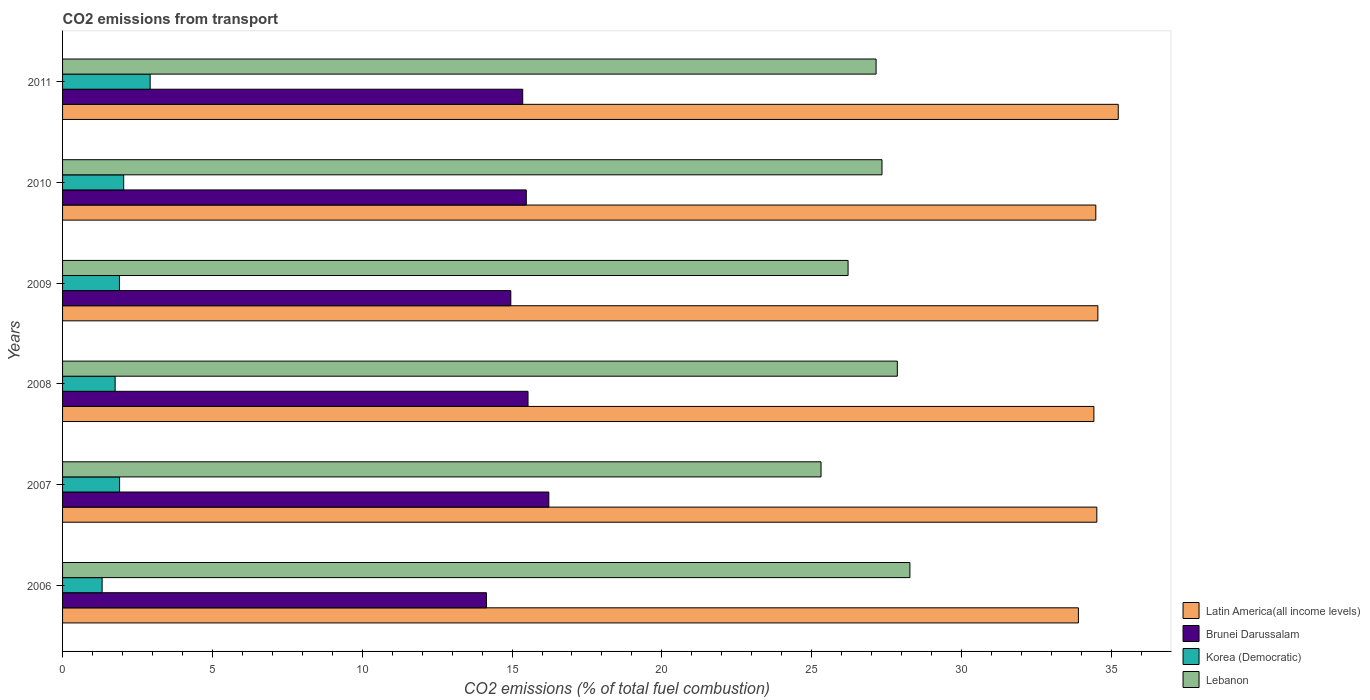Are the number of bars on each tick of the Y-axis equal?
Your answer should be very brief. Yes. How many bars are there on the 5th tick from the top?
Make the answer very short. 4. What is the total CO2 emitted in Lebanon in 2006?
Make the answer very short. 28.28. Across all years, what is the maximum total CO2 emitted in Latin America(all income levels)?
Your response must be concise. 35.23. Across all years, what is the minimum total CO2 emitted in Korea (Democratic)?
Make the answer very short. 1.32. In which year was the total CO2 emitted in Lebanon maximum?
Offer a very short reply. 2006. What is the total total CO2 emitted in Lebanon in the graph?
Your answer should be compact. 162.16. What is the difference between the total CO2 emitted in Lebanon in 2006 and that in 2010?
Give a very brief answer. 0.93. What is the difference between the total CO2 emitted in Korea (Democratic) in 2010 and the total CO2 emitted in Brunei Darussalam in 2008?
Your response must be concise. -13.49. What is the average total CO2 emitted in Brunei Darussalam per year?
Provide a short and direct response. 15.28. In the year 2010, what is the difference between the total CO2 emitted in Brunei Darussalam and total CO2 emitted in Latin America(all income levels)?
Offer a very short reply. -19.01. What is the ratio of the total CO2 emitted in Korea (Democratic) in 2008 to that in 2011?
Keep it short and to the point. 0.6. What is the difference between the highest and the second highest total CO2 emitted in Latin America(all income levels)?
Your answer should be compact. 0.68. What is the difference between the highest and the lowest total CO2 emitted in Latin America(all income levels)?
Ensure brevity in your answer.  1.33. What does the 2nd bar from the top in 2006 represents?
Make the answer very short. Korea (Democratic). What does the 2nd bar from the bottom in 2006 represents?
Your answer should be compact. Brunei Darussalam. How many bars are there?
Offer a terse response. 24. Are all the bars in the graph horizontal?
Offer a terse response. Yes. Does the graph contain any zero values?
Your answer should be compact. No. Does the graph contain grids?
Provide a short and direct response. No. How are the legend labels stacked?
Your answer should be very brief. Vertical. What is the title of the graph?
Make the answer very short. CO2 emissions from transport. Does "Bosnia and Herzegovina" appear as one of the legend labels in the graph?
Give a very brief answer. No. What is the label or title of the X-axis?
Make the answer very short. CO2 emissions (% of total fuel combustion). What is the CO2 emissions (% of total fuel combustion) of Latin America(all income levels) in 2006?
Your response must be concise. 33.9. What is the CO2 emissions (% of total fuel combustion) in Brunei Darussalam in 2006?
Offer a terse response. 14.15. What is the CO2 emissions (% of total fuel combustion) of Korea (Democratic) in 2006?
Offer a very short reply. 1.32. What is the CO2 emissions (% of total fuel combustion) in Lebanon in 2006?
Keep it short and to the point. 28.28. What is the CO2 emissions (% of total fuel combustion) of Latin America(all income levels) in 2007?
Keep it short and to the point. 34.52. What is the CO2 emissions (% of total fuel combustion) in Brunei Darussalam in 2007?
Keep it short and to the point. 16.23. What is the CO2 emissions (% of total fuel combustion) of Korea (Democratic) in 2007?
Give a very brief answer. 1.9. What is the CO2 emissions (% of total fuel combustion) of Lebanon in 2007?
Your answer should be compact. 25.31. What is the CO2 emissions (% of total fuel combustion) of Latin America(all income levels) in 2008?
Your answer should be very brief. 34.42. What is the CO2 emissions (% of total fuel combustion) in Brunei Darussalam in 2008?
Make the answer very short. 15.53. What is the CO2 emissions (% of total fuel combustion) in Korea (Democratic) in 2008?
Give a very brief answer. 1.75. What is the CO2 emissions (% of total fuel combustion) of Lebanon in 2008?
Your answer should be very brief. 27.86. What is the CO2 emissions (% of total fuel combustion) of Latin America(all income levels) in 2009?
Keep it short and to the point. 34.55. What is the CO2 emissions (% of total fuel combustion) in Brunei Darussalam in 2009?
Provide a succinct answer. 14.96. What is the CO2 emissions (% of total fuel combustion) of Korea (Democratic) in 2009?
Your answer should be compact. 1.9. What is the CO2 emissions (% of total fuel combustion) in Lebanon in 2009?
Provide a succinct answer. 26.22. What is the CO2 emissions (% of total fuel combustion) in Latin America(all income levels) in 2010?
Provide a succinct answer. 34.48. What is the CO2 emissions (% of total fuel combustion) in Brunei Darussalam in 2010?
Give a very brief answer. 15.48. What is the CO2 emissions (% of total fuel combustion) in Korea (Democratic) in 2010?
Your answer should be compact. 2.04. What is the CO2 emissions (% of total fuel combustion) in Lebanon in 2010?
Keep it short and to the point. 27.35. What is the CO2 emissions (% of total fuel combustion) of Latin America(all income levels) in 2011?
Give a very brief answer. 35.23. What is the CO2 emissions (% of total fuel combustion) in Brunei Darussalam in 2011?
Your answer should be very brief. 15.36. What is the CO2 emissions (% of total fuel combustion) of Korea (Democratic) in 2011?
Give a very brief answer. 2.92. What is the CO2 emissions (% of total fuel combustion) of Lebanon in 2011?
Your answer should be compact. 27.15. Across all years, what is the maximum CO2 emissions (% of total fuel combustion) of Latin America(all income levels)?
Offer a terse response. 35.23. Across all years, what is the maximum CO2 emissions (% of total fuel combustion) in Brunei Darussalam?
Keep it short and to the point. 16.23. Across all years, what is the maximum CO2 emissions (% of total fuel combustion) in Korea (Democratic)?
Offer a terse response. 2.92. Across all years, what is the maximum CO2 emissions (% of total fuel combustion) in Lebanon?
Your response must be concise. 28.28. Across all years, what is the minimum CO2 emissions (% of total fuel combustion) in Latin America(all income levels)?
Provide a short and direct response. 33.9. Across all years, what is the minimum CO2 emissions (% of total fuel combustion) of Brunei Darussalam?
Your answer should be very brief. 14.15. Across all years, what is the minimum CO2 emissions (% of total fuel combustion) of Korea (Democratic)?
Offer a terse response. 1.32. Across all years, what is the minimum CO2 emissions (% of total fuel combustion) in Lebanon?
Give a very brief answer. 25.31. What is the total CO2 emissions (% of total fuel combustion) of Latin America(all income levels) in the graph?
Provide a short and direct response. 207.1. What is the total CO2 emissions (% of total fuel combustion) in Brunei Darussalam in the graph?
Keep it short and to the point. 91.7. What is the total CO2 emissions (% of total fuel combustion) of Korea (Democratic) in the graph?
Offer a terse response. 11.84. What is the total CO2 emissions (% of total fuel combustion) in Lebanon in the graph?
Provide a short and direct response. 162.16. What is the difference between the CO2 emissions (% of total fuel combustion) in Latin America(all income levels) in 2006 and that in 2007?
Offer a terse response. -0.61. What is the difference between the CO2 emissions (% of total fuel combustion) in Brunei Darussalam in 2006 and that in 2007?
Provide a succinct answer. -2.08. What is the difference between the CO2 emissions (% of total fuel combustion) of Korea (Democratic) in 2006 and that in 2007?
Provide a succinct answer. -0.58. What is the difference between the CO2 emissions (% of total fuel combustion) in Lebanon in 2006 and that in 2007?
Your answer should be compact. 2.97. What is the difference between the CO2 emissions (% of total fuel combustion) of Latin America(all income levels) in 2006 and that in 2008?
Keep it short and to the point. -0.52. What is the difference between the CO2 emissions (% of total fuel combustion) in Brunei Darussalam in 2006 and that in 2008?
Provide a succinct answer. -1.39. What is the difference between the CO2 emissions (% of total fuel combustion) in Korea (Democratic) in 2006 and that in 2008?
Give a very brief answer. -0.43. What is the difference between the CO2 emissions (% of total fuel combustion) of Lebanon in 2006 and that in 2008?
Offer a very short reply. 0.42. What is the difference between the CO2 emissions (% of total fuel combustion) in Latin America(all income levels) in 2006 and that in 2009?
Keep it short and to the point. -0.65. What is the difference between the CO2 emissions (% of total fuel combustion) in Brunei Darussalam in 2006 and that in 2009?
Provide a succinct answer. -0.81. What is the difference between the CO2 emissions (% of total fuel combustion) of Korea (Democratic) in 2006 and that in 2009?
Your response must be concise. -0.58. What is the difference between the CO2 emissions (% of total fuel combustion) of Lebanon in 2006 and that in 2009?
Make the answer very short. 2.06. What is the difference between the CO2 emissions (% of total fuel combustion) in Latin America(all income levels) in 2006 and that in 2010?
Provide a short and direct response. -0.58. What is the difference between the CO2 emissions (% of total fuel combustion) of Brunei Darussalam in 2006 and that in 2010?
Provide a succinct answer. -1.33. What is the difference between the CO2 emissions (% of total fuel combustion) in Korea (Democratic) in 2006 and that in 2010?
Keep it short and to the point. -0.72. What is the difference between the CO2 emissions (% of total fuel combustion) of Lebanon in 2006 and that in 2010?
Your response must be concise. 0.93. What is the difference between the CO2 emissions (% of total fuel combustion) in Latin America(all income levels) in 2006 and that in 2011?
Your answer should be compact. -1.33. What is the difference between the CO2 emissions (% of total fuel combustion) in Brunei Darussalam in 2006 and that in 2011?
Keep it short and to the point. -1.21. What is the difference between the CO2 emissions (% of total fuel combustion) in Korea (Democratic) in 2006 and that in 2011?
Your answer should be very brief. -1.6. What is the difference between the CO2 emissions (% of total fuel combustion) in Lebanon in 2006 and that in 2011?
Keep it short and to the point. 1.13. What is the difference between the CO2 emissions (% of total fuel combustion) of Latin America(all income levels) in 2007 and that in 2008?
Give a very brief answer. 0.1. What is the difference between the CO2 emissions (% of total fuel combustion) in Brunei Darussalam in 2007 and that in 2008?
Make the answer very short. 0.69. What is the difference between the CO2 emissions (% of total fuel combustion) of Korea (Democratic) in 2007 and that in 2008?
Ensure brevity in your answer.  0.15. What is the difference between the CO2 emissions (% of total fuel combustion) in Lebanon in 2007 and that in 2008?
Your answer should be very brief. -2.55. What is the difference between the CO2 emissions (% of total fuel combustion) in Latin America(all income levels) in 2007 and that in 2009?
Your answer should be very brief. -0.03. What is the difference between the CO2 emissions (% of total fuel combustion) of Brunei Darussalam in 2007 and that in 2009?
Make the answer very short. 1.27. What is the difference between the CO2 emissions (% of total fuel combustion) of Korea (Democratic) in 2007 and that in 2009?
Offer a very short reply. 0. What is the difference between the CO2 emissions (% of total fuel combustion) of Lebanon in 2007 and that in 2009?
Ensure brevity in your answer.  -0.9. What is the difference between the CO2 emissions (% of total fuel combustion) of Latin America(all income levels) in 2007 and that in 2010?
Provide a succinct answer. 0.03. What is the difference between the CO2 emissions (% of total fuel combustion) of Brunei Darussalam in 2007 and that in 2010?
Your response must be concise. 0.75. What is the difference between the CO2 emissions (% of total fuel combustion) in Korea (Democratic) in 2007 and that in 2010?
Your answer should be compact. -0.14. What is the difference between the CO2 emissions (% of total fuel combustion) in Lebanon in 2007 and that in 2010?
Make the answer very short. -2.03. What is the difference between the CO2 emissions (% of total fuel combustion) in Latin America(all income levels) in 2007 and that in 2011?
Your answer should be very brief. -0.72. What is the difference between the CO2 emissions (% of total fuel combustion) of Brunei Darussalam in 2007 and that in 2011?
Offer a terse response. 0.87. What is the difference between the CO2 emissions (% of total fuel combustion) in Korea (Democratic) in 2007 and that in 2011?
Ensure brevity in your answer.  -1.02. What is the difference between the CO2 emissions (% of total fuel combustion) of Lebanon in 2007 and that in 2011?
Your response must be concise. -1.84. What is the difference between the CO2 emissions (% of total fuel combustion) of Latin America(all income levels) in 2008 and that in 2009?
Your answer should be very brief. -0.13. What is the difference between the CO2 emissions (% of total fuel combustion) in Brunei Darussalam in 2008 and that in 2009?
Offer a very short reply. 0.57. What is the difference between the CO2 emissions (% of total fuel combustion) in Korea (Democratic) in 2008 and that in 2009?
Offer a very short reply. -0.14. What is the difference between the CO2 emissions (% of total fuel combustion) of Lebanon in 2008 and that in 2009?
Ensure brevity in your answer.  1.64. What is the difference between the CO2 emissions (% of total fuel combustion) of Latin America(all income levels) in 2008 and that in 2010?
Your answer should be very brief. -0.06. What is the difference between the CO2 emissions (% of total fuel combustion) in Brunei Darussalam in 2008 and that in 2010?
Offer a very short reply. 0.06. What is the difference between the CO2 emissions (% of total fuel combustion) in Korea (Democratic) in 2008 and that in 2010?
Provide a succinct answer. -0.28. What is the difference between the CO2 emissions (% of total fuel combustion) in Lebanon in 2008 and that in 2010?
Provide a succinct answer. 0.51. What is the difference between the CO2 emissions (% of total fuel combustion) in Latin America(all income levels) in 2008 and that in 2011?
Give a very brief answer. -0.81. What is the difference between the CO2 emissions (% of total fuel combustion) of Brunei Darussalam in 2008 and that in 2011?
Offer a very short reply. 0.18. What is the difference between the CO2 emissions (% of total fuel combustion) in Korea (Democratic) in 2008 and that in 2011?
Provide a succinct answer. -1.17. What is the difference between the CO2 emissions (% of total fuel combustion) of Lebanon in 2008 and that in 2011?
Keep it short and to the point. 0.71. What is the difference between the CO2 emissions (% of total fuel combustion) of Latin America(all income levels) in 2009 and that in 2010?
Make the answer very short. 0.07. What is the difference between the CO2 emissions (% of total fuel combustion) of Brunei Darussalam in 2009 and that in 2010?
Make the answer very short. -0.52. What is the difference between the CO2 emissions (% of total fuel combustion) in Korea (Democratic) in 2009 and that in 2010?
Your answer should be compact. -0.14. What is the difference between the CO2 emissions (% of total fuel combustion) of Lebanon in 2009 and that in 2010?
Keep it short and to the point. -1.13. What is the difference between the CO2 emissions (% of total fuel combustion) of Latin America(all income levels) in 2009 and that in 2011?
Give a very brief answer. -0.68. What is the difference between the CO2 emissions (% of total fuel combustion) of Brunei Darussalam in 2009 and that in 2011?
Make the answer very short. -0.4. What is the difference between the CO2 emissions (% of total fuel combustion) of Korea (Democratic) in 2009 and that in 2011?
Keep it short and to the point. -1.02. What is the difference between the CO2 emissions (% of total fuel combustion) in Lebanon in 2009 and that in 2011?
Provide a short and direct response. -0.93. What is the difference between the CO2 emissions (% of total fuel combustion) of Latin America(all income levels) in 2010 and that in 2011?
Offer a very short reply. -0.75. What is the difference between the CO2 emissions (% of total fuel combustion) of Brunei Darussalam in 2010 and that in 2011?
Give a very brief answer. 0.12. What is the difference between the CO2 emissions (% of total fuel combustion) of Korea (Democratic) in 2010 and that in 2011?
Ensure brevity in your answer.  -0.88. What is the difference between the CO2 emissions (% of total fuel combustion) of Lebanon in 2010 and that in 2011?
Your response must be concise. 0.2. What is the difference between the CO2 emissions (% of total fuel combustion) in Latin America(all income levels) in 2006 and the CO2 emissions (% of total fuel combustion) in Brunei Darussalam in 2007?
Your response must be concise. 17.67. What is the difference between the CO2 emissions (% of total fuel combustion) in Latin America(all income levels) in 2006 and the CO2 emissions (% of total fuel combustion) in Korea (Democratic) in 2007?
Make the answer very short. 32. What is the difference between the CO2 emissions (% of total fuel combustion) of Latin America(all income levels) in 2006 and the CO2 emissions (% of total fuel combustion) of Lebanon in 2007?
Ensure brevity in your answer.  8.59. What is the difference between the CO2 emissions (% of total fuel combustion) of Brunei Darussalam in 2006 and the CO2 emissions (% of total fuel combustion) of Korea (Democratic) in 2007?
Make the answer very short. 12.24. What is the difference between the CO2 emissions (% of total fuel combustion) of Brunei Darussalam in 2006 and the CO2 emissions (% of total fuel combustion) of Lebanon in 2007?
Ensure brevity in your answer.  -11.17. What is the difference between the CO2 emissions (% of total fuel combustion) in Korea (Democratic) in 2006 and the CO2 emissions (% of total fuel combustion) in Lebanon in 2007?
Provide a succinct answer. -23.99. What is the difference between the CO2 emissions (% of total fuel combustion) of Latin America(all income levels) in 2006 and the CO2 emissions (% of total fuel combustion) of Brunei Darussalam in 2008?
Offer a very short reply. 18.37. What is the difference between the CO2 emissions (% of total fuel combustion) of Latin America(all income levels) in 2006 and the CO2 emissions (% of total fuel combustion) of Korea (Democratic) in 2008?
Provide a short and direct response. 32.15. What is the difference between the CO2 emissions (% of total fuel combustion) of Latin America(all income levels) in 2006 and the CO2 emissions (% of total fuel combustion) of Lebanon in 2008?
Offer a very short reply. 6.04. What is the difference between the CO2 emissions (% of total fuel combustion) of Brunei Darussalam in 2006 and the CO2 emissions (% of total fuel combustion) of Korea (Democratic) in 2008?
Your answer should be compact. 12.39. What is the difference between the CO2 emissions (% of total fuel combustion) of Brunei Darussalam in 2006 and the CO2 emissions (% of total fuel combustion) of Lebanon in 2008?
Make the answer very short. -13.71. What is the difference between the CO2 emissions (% of total fuel combustion) in Korea (Democratic) in 2006 and the CO2 emissions (% of total fuel combustion) in Lebanon in 2008?
Keep it short and to the point. -26.54. What is the difference between the CO2 emissions (% of total fuel combustion) of Latin America(all income levels) in 2006 and the CO2 emissions (% of total fuel combustion) of Brunei Darussalam in 2009?
Provide a short and direct response. 18.94. What is the difference between the CO2 emissions (% of total fuel combustion) in Latin America(all income levels) in 2006 and the CO2 emissions (% of total fuel combustion) in Korea (Democratic) in 2009?
Your answer should be very brief. 32. What is the difference between the CO2 emissions (% of total fuel combustion) in Latin America(all income levels) in 2006 and the CO2 emissions (% of total fuel combustion) in Lebanon in 2009?
Your answer should be compact. 7.69. What is the difference between the CO2 emissions (% of total fuel combustion) in Brunei Darussalam in 2006 and the CO2 emissions (% of total fuel combustion) in Korea (Democratic) in 2009?
Keep it short and to the point. 12.25. What is the difference between the CO2 emissions (% of total fuel combustion) in Brunei Darussalam in 2006 and the CO2 emissions (% of total fuel combustion) in Lebanon in 2009?
Offer a terse response. -12.07. What is the difference between the CO2 emissions (% of total fuel combustion) of Korea (Democratic) in 2006 and the CO2 emissions (% of total fuel combustion) of Lebanon in 2009?
Keep it short and to the point. -24.89. What is the difference between the CO2 emissions (% of total fuel combustion) of Latin America(all income levels) in 2006 and the CO2 emissions (% of total fuel combustion) of Brunei Darussalam in 2010?
Keep it short and to the point. 18.43. What is the difference between the CO2 emissions (% of total fuel combustion) of Latin America(all income levels) in 2006 and the CO2 emissions (% of total fuel combustion) of Korea (Democratic) in 2010?
Keep it short and to the point. 31.86. What is the difference between the CO2 emissions (% of total fuel combustion) of Latin America(all income levels) in 2006 and the CO2 emissions (% of total fuel combustion) of Lebanon in 2010?
Provide a short and direct response. 6.55. What is the difference between the CO2 emissions (% of total fuel combustion) of Brunei Darussalam in 2006 and the CO2 emissions (% of total fuel combustion) of Korea (Democratic) in 2010?
Provide a succinct answer. 12.11. What is the difference between the CO2 emissions (% of total fuel combustion) of Brunei Darussalam in 2006 and the CO2 emissions (% of total fuel combustion) of Lebanon in 2010?
Your response must be concise. -13.2. What is the difference between the CO2 emissions (% of total fuel combustion) in Korea (Democratic) in 2006 and the CO2 emissions (% of total fuel combustion) in Lebanon in 2010?
Give a very brief answer. -26.03. What is the difference between the CO2 emissions (% of total fuel combustion) of Latin America(all income levels) in 2006 and the CO2 emissions (% of total fuel combustion) of Brunei Darussalam in 2011?
Make the answer very short. 18.54. What is the difference between the CO2 emissions (% of total fuel combustion) in Latin America(all income levels) in 2006 and the CO2 emissions (% of total fuel combustion) in Korea (Democratic) in 2011?
Your answer should be very brief. 30.98. What is the difference between the CO2 emissions (% of total fuel combustion) in Latin America(all income levels) in 2006 and the CO2 emissions (% of total fuel combustion) in Lebanon in 2011?
Provide a succinct answer. 6.75. What is the difference between the CO2 emissions (% of total fuel combustion) in Brunei Darussalam in 2006 and the CO2 emissions (% of total fuel combustion) in Korea (Democratic) in 2011?
Keep it short and to the point. 11.22. What is the difference between the CO2 emissions (% of total fuel combustion) of Brunei Darussalam in 2006 and the CO2 emissions (% of total fuel combustion) of Lebanon in 2011?
Your answer should be compact. -13. What is the difference between the CO2 emissions (% of total fuel combustion) of Korea (Democratic) in 2006 and the CO2 emissions (% of total fuel combustion) of Lebanon in 2011?
Your answer should be compact. -25.83. What is the difference between the CO2 emissions (% of total fuel combustion) in Latin America(all income levels) in 2007 and the CO2 emissions (% of total fuel combustion) in Brunei Darussalam in 2008?
Offer a terse response. 18.98. What is the difference between the CO2 emissions (% of total fuel combustion) in Latin America(all income levels) in 2007 and the CO2 emissions (% of total fuel combustion) in Korea (Democratic) in 2008?
Provide a succinct answer. 32.76. What is the difference between the CO2 emissions (% of total fuel combustion) in Latin America(all income levels) in 2007 and the CO2 emissions (% of total fuel combustion) in Lebanon in 2008?
Keep it short and to the point. 6.66. What is the difference between the CO2 emissions (% of total fuel combustion) in Brunei Darussalam in 2007 and the CO2 emissions (% of total fuel combustion) in Korea (Democratic) in 2008?
Your answer should be compact. 14.47. What is the difference between the CO2 emissions (% of total fuel combustion) of Brunei Darussalam in 2007 and the CO2 emissions (% of total fuel combustion) of Lebanon in 2008?
Keep it short and to the point. -11.63. What is the difference between the CO2 emissions (% of total fuel combustion) of Korea (Democratic) in 2007 and the CO2 emissions (% of total fuel combustion) of Lebanon in 2008?
Offer a terse response. -25.96. What is the difference between the CO2 emissions (% of total fuel combustion) in Latin America(all income levels) in 2007 and the CO2 emissions (% of total fuel combustion) in Brunei Darussalam in 2009?
Give a very brief answer. 19.56. What is the difference between the CO2 emissions (% of total fuel combustion) of Latin America(all income levels) in 2007 and the CO2 emissions (% of total fuel combustion) of Korea (Democratic) in 2009?
Offer a terse response. 32.62. What is the difference between the CO2 emissions (% of total fuel combustion) of Latin America(all income levels) in 2007 and the CO2 emissions (% of total fuel combustion) of Lebanon in 2009?
Make the answer very short. 8.3. What is the difference between the CO2 emissions (% of total fuel combustion) of Brunei Darussalam in 2007 and the CO2 emissions (% of total fuel combustion) of Korea (Democratic) in 2009?
Your answer should be compact. 14.33. What is the difference between the CO2 emissions (% of total fuel combustion) of Brunei Darussalam in 2007 and the CO2 emissions (% of total fuel combustion) of Lebanon in 2009?
Your response must be concise. -9.99. What is the difference between the CO2 emissions (% of total fuel combustion) in Korea (Democratic) in 2007 and the CO2 emissions (% of total fuel combustion) in Lebanon in 2009?
Give a very brief answer. -24.31. What is the difference between the CO2 emissions (% of total fuel combustion) in Latin America(all income levels) in 2007 and the CO2 emissions (% of total fuel combustion) in Brunei Darussalam in 2010?
Make the answer very short. 19.04. What is the difference between the CO2 emissions (% of total fuel combustion) in Latin America(all income levels) in 2007 and the CO2 emissions (% of total fuel combustion) in Korea (Democratic) in 2010?
Your answer should be very brief. 32.48. What is the difference between the CO2 emissions (% of total fuel combustion) of Latin America(all income levels) in 2007 and the CO2 emissions (% of total fuel combustion) of Lebanon in 2010?
Make the answer very short. 7.17. What is the difference between the CO2 emissions (% of total fuel combustion) in Brunei Darussalam in 2007 and the CO2 emissions (% of total fuel combustion) in Korea (Democratic) in 2010?
Ensure brevity in your answer.  14.19. What is the difference between the CO2 emissions (% of total fuel combustion) of Brunei Darussalam in 2007 and the CO2 emissions (% of total fuel combustion) of Lebanon in 2010?
Provide a short and direct response. -11.12. What is the difference between the CO2 emissions (% of total fuel combustion) of Korea (Democratic) in 2007 and the CO2 emissions (% of total fuel combustion) of Lebanon in 2010?
Keep it short and to the point. -25.44. What is the difference between the CO2 emissions (% of total fuel combustion) of Latin America(all income levels) in 2007 and the CO2 emissions (% of total fuel combustion) of Brunei Darussalam in 2011?
Make the answer very short. 19.16. What is the difference between the CO2 emissions (% of total fuel combustion) of Latin America(all income levels) in 2007 and the CO2 emissions (% of total fuel combustion) of Korea (Democratic) in 2011?
Your answer should be compact. 31.59. What is the difference between the CO2 emissions (% of total fuel combustion) in Latin America(all income levels) in 2007 and the CO2 emissions (% of total fuel combustion) in Lebanon in 2011?
Your response must be concise. 7.37. What is the difference between the CO2 emissions (% of total fuel combustion) in Brunei Darussalam in 2007 and the CO2 emissions (% of total fuel combustion) in Korea (Democratic) in 2011?
Your answer should be compact. 13.31. What is the difference between the CO2 emissions (% of total fuel combustion) of Brunei Darussalam in 2007 and the CO2 emissions (% of total fuel combustion) of Lebanon in 2011?
Your answer should be very brief. -10.92. What is the difference between the CO2 emissions (% of total fuel combustion) of Korea (Democratic) in 2007 and the CO2 emissions (% of total fuel combustion) of Lebanon in 2011?
Give a very brief answer. -25.25. What is the difference between the CO2 emissions (% of total fuel combustion) in Latin America(all income levels) in 2008 and the CO2 emissions (% of total fuel combustion) in Brunei Darussalam in 2009?
Make the answer very short. 19.46. What is the difference between the CO2 emissions (% of total fuel combustion) of Latin America(all income levels) in 2008 and the CO2 emissions (% of total fuel combustion) of Korea (Democratic) in 2009?
Ensure brevity in your answer.  32.52. What is the difference between the CO2 emissions (% of total fuel combustion) in Latin America(all income levels) in 2008 and the CO2 emissions (% of total fuel combustion) in Lebanon in 2009?
Your answer should be compact. 8.2. What is the difference between the CO2 emissions (% of total fuel combustion) in Brunei Darussalam in 2008 and the CO2 emissions (% of total fuel combustion) in Korea (Democratic) in 2009?
Keep it short and to the point. 13.64. What is the difference between the CO2 emissions (% of total fuel combustion) of Brunei Darussalam in 2008 and the CO2 emissions (% of total fuel combustion) of Lebanon in 2009?
Offer a very short reply. -10.68. What is the difference between the CO2 emissions (% of total fuel combustion) in Korea (Democratic) in 2008 and the CO2 emissions (% of total fuel combustion) in Lebanon in 2009?
Your answer should be compact. -24.46. What is the difference between the CO2 emissions (% of total fuel combustion) in Latin America(all income levels) in 2008 and the CO2 emissions (% of total fuel combustion) in Brunei Darussalam in 2010?
Provide a succinct answer. 18.94. What is the difference between the CO2 emissions (% of total fuel combustion) of Latin America(all income levels) in 2008 and the CO2 emissions (% of total fuel combustion) of Korea (Democratic) in 2010?
Keep it short and to the point. 32.38. What is the difference between the CO2 emissions (% of total fuel combustion) in Latin America(all income levels) in 2008 and the CO2 emissions (% of total fuel combustion) in Lebanon in 2010?
Provide a short and direct response. 7.07. What is the difference between the CO2 emissions (% of total fuel combustion) of Brunei Darussalam in 2008 and the CO2 emissions (% of total fuel combustion) of Korea (Democratic) in 2010?
Ensure brevity in your answer.  13.49. What is the difference between the CO2 emissions (% of total fuel combustion) of Brunei Darussalam in 2008 and the CO2 emissions (% of total fuel combustion) of Lebanon in 2010?
Keep it short and to the point. -11.81. What is the difference between the CO2 emissions (% of total fuel combustion) in Korea (Democratic) in 2008 and the CO2 emissions (% of total fuel combustion) in Lebanon in 2010?
Your answer should be very brief. -25.59. What is the difference between the CO2 emissions (% of total fuel combustion) in Latin America(all income levels) in 2008 and the CO2 emissions (% of total fuel combustion) in Brunei Darussalam in 2011?
Provide a succinct answer. 19.06. What is the difference between the CO2 emissions (% of total fuel combustion) in Latin America(all income levels) in 2008 and the CO2 emissions (% of total fuel combustion) in Korea (Democratic) in 2011?
Your answer should be compact. 31.5. What is the difference between the CO2 emissions (% of total fuel combustion) of Latin America(all income levels) in 2008 and the CO2 emissions (% of total fuel combustion) of Lebanon in 2011?
Give a very brief answer. 7.27. What is the difference between the CO2 emissions (% of total fuel combustion) in Brunei Darussalam in 2008 and the CO2 emissions (% of total fuel combustion) in Korea (Democratic) in 2011?
Provide a short and direct response. 12.61. What is the difference between the CO2 emissions (% of total fuel combustion) in Brunei Darussalam in 2008 and the CO2 emissions (% of total fuel combustion) in Lebanon in 2011?
Make the answer very short. -11.62. What is the difference between the CO2 emissions (% of total fuel combustion) in Korea (Democratic) in 2008 and the CO2 emissions (% of total fuel combustion) in Lebanon in 2011?
Your answer should be very brief. -25.4. What is the difference between the CO2 emissions (% of total fuel combustion) of Latin America(all income levels) in 2009 and the CO2 emissions (% of total fuel combustion) of Brunei Darussalam in 2010?
Give a very brief answer. 19.07. What is the difference between the CO2 emissions (% of total fuel combustion) in Latin America(all income levels) in 2009 and the CO2 emissions (% of total fuel combustion) in Korea (Democratic) in 2010?
Provide a succinct answer. 32.51. What is the difference between the CO2 emissions (% of total fuel combustion) in Latin America(all income levels) in 2009 and the CO2 emissions (% of total fuel combustion) in Lebanon in 2010?
Your answer should be very brief. 7.2. What is the difference between the CO2 emissions (% of total fuel combustion) in Brunei Darussalam in 2009 and the CO2 emissions (% of total fuel combustion) in Korea (Democratic) in 2010?
Your answer should be very brief. 12.92. What is the difference between the CO2 emissions (% of total fuel combustion) in Brunei Darussalam in 2009 and the CO2 emissions (% of total fuel combustion) in Lebanon in 2010?
Offer a very short reply. -12.39. What is the difference between the CO2 emissions (% of total fuel combustion) of Korea (Democratic) in 2009 and the CO2 emissions (% of total fuel combustion) of Lebanon in 2010?
Your response must be concise. -25.45. What is the difference between the CO2 emissions (% of total fuel combustion) of Latin America(all income levels) in 2009 and the CO2 emissions (% of total fuel combustion) of Brunei Darussalam in 2011?
Your answer should be compact. 19.19. What is the difference between the CO2 emissions (% of total fuel combustion) in Latin America(all income levels) in 2009 and the CO2 emissions (% of total fuel combustion) in Korea (Democratic) in 2011?
Your response must be concise. 31.63. What is the difference between the CO2 emissions (% of total fuel combustion) of Latin America(all income levels) in 2009 and the CO2 emissions (% of total fuel combustion) of Lebanon in 2011?
Offer a very short reply. 7.4. What is the difference between the CO2 emissions (% of total fuel combustion) in Brunei Darussalam in 2009 and the CO2 emissions (% of total fuel combustion) in Korea (Democratic) in 2011?
Keep it short and to the point. 12.04. What is the difference between the CO2 emissions (% of total fuel combustion) in Brunei Darussalam in 2009 and the CO2 emissions (% of total fuel combustion) in Lebanon in 2011?
Ensure brevity in your answer.  -12.19. What is the difference between the CO2 emissions (% of total fuel combustion) of Korea (Democratic) in 2009 and the CO2 emissions (% of total fuel combustion) of Lebanon in 2011?
Offer a terse response. -25.25. What is the difference between the CO2 emissions (% of total fuel combustion) in Latin America(all income levels) in 2010 and the CO2 emissions (% of total fuel combustion) in Brunei Darussalam in 2011?
Offer a very short reply. 19.13. What is the difference between the CO2 emissions (% of total fuel combustion) in Latin America(all income levels) in 2010 and the CO2 emissions (% of total fuel combustion) in Korea (Democratic) in 2011?
Make the answer very short. 31.56. What is the difference between the CO2 emissions (% of total fuel combustion) of Latin America(all income levels) in 2010 and the CO2 emissions (% of total fuel combustion) of Lebanon in 2011?
Your response must be concise. 7.33. What is the difference between the CO2 emissions (% of total fuel combustion) of Brunei Darussalam in 2010 and the CO2 emissions (% of total fuel combustion) of Korea (Democratic) in 2011?
Make the answer very short. 12.55. What is the difference between the CO2 emissions (% of total fuel combustion) in Brunei Darussalam in 2010 and the CO2 emissions (% of total fuel combustion) in Lebanon in 2011?
Give a very brief answer. -11.67. What is the difference between the CO2 emissions (% of total fuel combustion) of Korea (Democratic) in 2010 and the CO2 emissions (% of total fuel combustion) of Lebanon in 2011?
Offer a very short reply. -25.11. What is the average CO2 emissions (% of total fuel combustion) of Latin America(all income levels) per year?
Keep it short and to the point. 34.52. What is the average CO2 emissions (% of total fuel combustion) of Brunei Darussalam per year?
Offer a very short reply. 15.28. What is the average CO2 emissions (% of total fuel combustion) of Korea (Democratic) per year?
Make the answer very short. 1.97. What is the average CO2 emissions (% of total fuel combustion) of Lebanon per year?
Your response must be concise. 27.03. In the year 2006, what is the difference between the CO2 emissions (% of total fuel combustion) in Latin America(all income levels) and CO2 emissions (% of total fuel combustion) in Brunei Darussalam?
Provide a succinct answer. 19.75. In the year 2006, what is the difference between the CO2 emissions (% of total fuel combustion) of Latin America(all income levels) and CO2 emissions (% of total fuel combustion) of Korea (Democratic)?
Your answer should be compact. 32.58. In the year 2006, what is the difference between the CO2 emissions (% of total fuel combustion) in Latin America(all income levels) and CO2 emissions (% of total fuel combustion) in Lebanon?
Ensure brevity in your answer.  5.62. In the year 2006, what is the difference between the CO2 emissions (% of total fuel combustion) in Brunei Darussalam and CO2 emissions (% of total fuel combustion) in Korea (Democratic)?
Keep it short and to the point. 12.83. In the year 2006, what is the difference between the CO2 emissions (% of total fuel combustion) of Brunei Darussalam and CO2 emissions (% of total fuel combustion) of Lebanon?
Your response must be concise. -14.13. In the year 2006, what is the difference between the CO2 emissions (% of total fuel combustion) of Korea (Democratic) and CO2 emissions (% of total fuel combustion) of Lebanon?
Your answer should be compact. -26.96. In the year 2007, what is the difference between the CO2 emissions (% of total fuel combustion) of Latin America(all income levels) and CO2 emissions (% of total fuel combustion) of Brunei Darussalam?
Keep it short and to the point. 18.29. In the year 2007, what is the difference between the CO2 emissions (% of total fuel combustion) in Latin America(all income levels) and CO2 emissions (% of total fuel combustion) in Korea (Democratic)?
Provide a succinct answer. 32.61. In the year 2007, what is the difference between the CO2 emissions (% of total fuel combustion) in Latin America(all income levels) and CO2 emissions (% of total fuel combustion) in Lebanon?
Your answer should be compact. 9.2. In the year 2007, what is the difference between the CO2 emissions (% of total fuel combustion) in Brunei Darussalam and CO2 emissions (% of total fuel combustion) in Korea (Democratic)?
Provide a short and direct response. 14.32. In the year 2007, what is the difference between the CO2 emissions (% of total fuel combustion) in Brunei Darussalam and CO2 emissions (% of total fuel combustion) in Lebanon?
Make the answer very short. -9.08. In the year 2007, what is the difference between the CO2 emissions (% of total fuel combustion) of Korea (Democratic) and CO2 emissions (% of total fuel combustion) of Lebanon?
Provide a succinct answer. -23.41. In the year 2008, what is the difference between the CO2 emissions (% of total fuel combustion) of Latin America(all income levels) and CO2 emissions (% of total fuel combustion) of Brunei Darussalam?
Provide a succinct answer. 18.88. In the year 2008, what is the difference between the CO2 emissions (% of total fuel combustion) in Latin America(all income levels) and CO2 emissions (% of total fuel combustion) in Korea (Democratic)?
Provide a succinct answer. 32.66. In the year 2008, what is the difference between the CO2 emissions (% of total fuel combustion) in Latin America(all income levels) and CO2 emissions (% of total fuel combustion) in Lebanon?
Your response must be concise. 6.56. In the year 2008, what is the difference between the CO2 emissions (% of total fuel combustion) of Brunei Darussalam and CO2 emissions (% of total fuel combustion) of Korea (Democratic)?
Your response must be concise. 13.78. In the year 2008, what is the difference between the CO2 emissions (% of total fuel combustion) in Brunei Darussalam and CO2 emissions (% of total fuel combustion) in Lebanon?
Provide a short and direct response. -12.32. In the year 2008, what is the difference between the CO2 emissions (% of total fuel combustion) of Korea (Democratic) and CO2 emissions (% of total fuel combustion) of Lebanon?
Make the answer very short. -26.1. In the year 2009, what is the difference between the CO2 emissions (% of total fuel combustion) of Latin America(all income levels) and CO2 emissions (% of total fuel combustion) of Brunei Darussalam?
Make the answer very short. 19.59. In the year 2009, what is the difference between the CO2 emissions (% of total fuel combustion) in Latin America(all income levels) and CO2 emissions (% of total fuel combustion) in Korea (Democratic)?
Offer a terse response. 32.65. In the year 2009, what is the difference between the CO2 emissions (% of total fuel combustion) in Latin America(all income levels) and CO2 emissions (% of total fuel combustion) in Lebanon?
Ensure brevity in your answer.  8.34. In the year 2009, what is the difference between the CO2 emissions (% of total fuel combustion) in Brunei Darussalam and CO2 emissions (% of total fuel combustion) in Korea (Democratic)?
Your answer should be very brief. 13.06. In the year 2009, what is the difference between the CO2 emissions (% of total fuel combustion) of Brunei Darussalam and CO2 emissions (% of total fuel combustion) of Lebanon?
Your answer should be very brief. -11.26. In the year 2009, what is the difference between the CO2 emissions (% of total fuel combustion) in Korea (Democratic) and CO2 emissions (% of total fuel combustion) in Lebanon?
Keep it short and to the point. -24.32. In the year 2010, what is the difference between the CO2 emissions (% of total fuel combustion) of Latin America(all income levels) and CO2 emissions (% of total fuel combustion) of Brunei Darussalam?
Offer a very short reply. 19.01. In the year 2010, what is the difference between the CO2 emissions (% of total fuel combustion) of Latin America(all income levels) and CO2 emissions (% of total fuel combustion) of Korea (Democratic)?
Provide a succinct answer. 32.44. In the year 2010, what is the difference between the CO2 emissions (% of total fuel combustion) in Latin America(all income levels) and CO2 emissions (% of total fuel combustion) in Lebanon?
Keep it short and to the point. 7.14. In the year 2010, what is the difference between the CO2 emissions (% of total fuel combustion) in Brunei Darussalam and CO2 emissions (% of total fuel combustion) in Korea (Democratic)?
Provide a short and direct response. 13.44. In the year 2010, what is the difference between the CO2 emissions (% of total fuel combustion) in Brunei Darussalam and CO2 emissions (% of total fuel combustion) in Lebanon?
Keep it short and to the point. -11.87. In the year 2010, what is the difference between the CO2 emissions (% of total fuel combustion) in Korea (Democratic) and CO2 emissions (% of total fuel combustion) in Lebanon?
Your answer should be very brief. -25.31. In the year 2011, what is the difference between the CO2 emissions (% of total fuel combustion) in Latin America(all income levels) and CO2 emissions (% of total fuel combustion) in Brunei Darussalam?
Your response must be concise. 19.87. In the year 2011, what is the difference between the CO2 emissions (% of total fuel combustion) in Latin America(all income levels) and CO2 emissions (% of total fuel combustion) in Korea (Democratic)?
Provide a short and direct response. 32.31. In the year 2011, what is the difference between the CO2 emissions (% of total fuel combustion) of Latin America(all income levels) and CO2 emissions (% of total fuel combustion) of Lebanon?
Your response must be concise. 8.08. In the year 2011, what is the difference between the CO2 emissions (% of total fuel combustion) of Brunei Darussalam and CO2 emissions (% of total fuel combustion) of Korea (Democratic)?
Your response must be concise. 12.43. In the year 2011, what is the difference between the CO2 emissions (% of total fuel combustion) of Brunei Darussalam and CO2 emissions (% of total fuel combustion) of Lebanon?
Give a very brief answer. -11.79. In the year 2011, what is the difference between the CO2 emissions (% of total fuel combustion) of Korea (Democratic) and CO2 emissions (% of total fuel combustion) of Lebanon?
Provide a short and direct response. -24.23. What is the ratio of the CO2 emissions (% of total fuel combustion) of Latin America(all income levels) in 2006 to that in 2007?
Provide a succinct answer. 0.98. What is the ratio of the CO2 emissions (% of total fuel combustion) in Brunei Darussalam in 2006 to that in 2007?
Provide a succinct answer. 0.87. What is the ratio of the CO2 emissions (% of total fuel combustion) in Korea (Democratic) in 2006 to that in 2007?
Offer a very short reply. 0.69. What is the ratio of the CO2 emissions (% of total fuel combustion) in Lebanon in 2006 to that in 2007?
Offer a very short reply. 1.12. What is the ratio of the CO2 emissions (% of total fuel combustion) in Brunei Darussalam in 2006 to that in 2008?
Offer a terse response. 0.91. What is the ratio of the CO2 emissions (% of total fuel combustion) in Korea (Democratic) in 2006 to that in 2008?
Ensure brevity in your answer.  0.75. What is the ratio of the CO2 emissions (% of total fuel combustion) in Lebanon in 2006 to that in 2008?
Provide a short and direct response. 1.02. What is the ratio of the CO2 emissions (% of total fuel combustion) of Latin America(all income levels) in 2006 to that in 2009?
Make the answer very short. 0.98. What is the ratio of the CO2 emissions (% of total fuel combustion) of Brunei Darussalam in 2006 to that in 2009?
Offer a terse response. 0.95. What is the ratio of the CO2 emissions (% of total fuel combustion) of Korea (Democratic) in 2006 to that in 2009?
Provide a succinct answer. 0.7. What is the ratio of the CO2 emissions (% of total fuel combustion) in Lebanon in 2006 to that in 2009?
Ensure brevity in your answer.  1.08. What is the ratio of the CO2 emissions (% of total fuel combustion) of Latin America(all income levels) in 2006 to that in 2010?
Your response must be concise. 0.98. What is the ratio of the CO2 emissions (% of total fuel combustion) in Brunei Darussalam in 2006 to that in 2010?
Offer a very short reply. 0.91. What is the ratio of the CO2 emissions (% of total fuel combustion) in Korea (Democratic) in 2006 to that in 2010?
Offer a very short reply. 0.65. What is the ratio of the CO2 emissions (% of total fuel combustion) of Lebanon in 2006 to that in 2010?
Give a very brief answer. 1.03. What is the ratio of the CO2 emissions (% of total fuel combustion) in Latin America(all income levels) in 2006 to that in 2011?
Your answer should be compact. 0.96. What is the ratio of the CO2 emissions (% of total fuel combustion) in Brunei Darussalam in 2006 to that in 2011?
Your answer should be very brief. 0.92. What is the ratio of the CO2 emissions (% of total fuel combustion) in Korea (Democratic) in 2006 to that in 2011?
Make the answer very short. 0.45. What is the ratio of the CO2 emissions (% of total fuel combustion) of Lebanon in 2006 to that in 2011?
Your answer should be very brief. 1.04. What is the ratio of the CO2 emissions (% of total fuel combustion) in Latin America(all income levels) in 2007 to that in 2008?
Your response must be concise. 1. What is the ratio of the CO2 emissions (% of total fuel combustion) of Brunei Darussalam in 2007 to that in 2008?
Your answer should be very brief. 1.04. What is the ratio of the CO2 emissions (% of total fuel combustion) of Korea (Democratic) in 2007 to that in 2008?
Your response must be concise. 1.08. What is the ratio of the CO2 emissions (% of total fuel combustion) of Lebanon in 2007 to that in 2008?
Your answer should be compact. 0.91. What is the ratio of the CO2 emissions (% of total fuel combustion) in Brunei Darussalam in 2007 to that in 2009?
Your answer should be very brief. 1.08. What is the ratio of the CO2 emissions (% of total fuel combustion) in Korea (Democratic) in 2007 to that in 2009?
Your answer should be very brief. 1. What is the ratio of the CO2 emissions (% of total fuel combustion) of Lebanon in 2007 to that in 2009?
Offer a terse response. 0.97. What is the ratio of the CO2 emissions (% of total fuel combustion) of Latin America(all income levels) in 2007 to that in 2010?
Your response must be concise. 1. What is the ratio of the CO2 emissions (% of total fuel combustion) in Brunei Darussalam in 2007 to that in 2010?
Provide a succinct answer. 1.05. What is the ratio of the CO2 emissions (% of total fuel combustion) of Korea (Democratic) in 2007 to that in 2010?
Provide a short and direct response. 0.93. What is the ratio of the CO2 emissions (% of total fuel combustion) in Lebanon in 2007 to that in 2010?
Your answer should be very brief. 0.93. What is the ratio of the CO2 emissions (% of total fuel combustion) in Latin America(all income levels) in 2007 to that in 2011?
Keep it short and to the point. 0.98. What is the ratio of the CO2 emissions (% of total fuel combustion) of Brunei Darussalam in 2007 to that in 2011?
Provide a short and direct response. 1.06. What is the ratio of the CO2 emissions (% of total fuel combustion) in Korea (Democratic) in 2007 to that in 2011?
Make the answer very short. 0.65. What is the ratio of the CO2 emissions (% of total fuel combustion) in Lebanon in 2007 to that in 2011?
Offer a very short reply. 0.93. What is the ratio of the CO2 emissions (% of total fuel combustion) in Latin America(all income levels) in 2008 to that in 2009?
Provide a short and direct response. 1. What is the ratio of the CO2 emissions (% of total fuel combustion) in Brunei Darussalam in 2008 to that in 2009?
Give a very brief answer. 1.04. What is the ratio of the CO2 emissions (% of total fuel combustion) in Korea (Democratic) in 2008 to that in 2009?
Ensure brevity in your answer.  0.92. What is the ratio of the CO2 emissions (% of total fuel combustion) of Lebanon in 2008 to that in 2009?
Your answer should be very brief. 1.06. What is the ratio of the CO2 emissions (% of total fuel combustion) of Korea (Democratic) in 2008 to that in 2010?
Ensure brevity in your answer.  0.86. What is the ratio of the CO2 emissions (% of total fuel combustion) of Lebanon in 2008 to that in 2010?
Give a very brief answer. 1.02. What is the ratio of the CO2 emissions (% of total fuel combustion) in Latin America(all income levels) in 2008 to that in 2011?
Your answer should be very brief. 0.98. What is the ratio of the CO2 emissions (% of total fuel combustion) in Brunei Darussalam in 2008 to that in 2011?
Keep it short and to the point. 1.01. What is the ratio of the CO2 emissions (% of total fuel combustion) of Korea (Democratic) in 2008 to that in 2011?
Offer a very short reply. 0.6. What is the ratio of the CO2 emissions (% of total fuel combustion) in Lebanon in 2008 to that in 2011?
Make the answer very short. 1.03. What is the ratio of the CO2 emissions (% of total fuel combustion) of Latin America(all income levels) in 2009 to that in 2010?
Your response must be concise. 1. What is the ratio of the CO2 emissions (% of total fuel combustion) of Brunei Darussalam in 2009 to that in 2010?
Offer a very short reply. 0.97. What is the ratio of the CO2 emissions (% of total fuel combustion) of Korea (Democratic) in 2009 to that in 2010?
Your answer should be very brief. 0.93. What is the ratio of the CO2 emissions (% of total fuel combustion) in Lebanon in 2009 to that in 2010?
Ensure brevity in your answer.  0.96. What is the ratio of the CO2 emissions (% of total fuel combustion) in Latin America(all income levels) in 2009 to that in 2011?
Provide a succinct answer. 0.98. What is the ratio of the CO2 emissions (% of total fuel combustion) of Brunei Darussalam in 2009 to that in 2011?
Your response must be concise. 0.97. What is the ratio of the CO2 emissions (% of total fuel combustion) of Korea (Democratic) in 2009 to that in 2011?
Your response must be concise. 0.65. What is the ratio of the CO2 emissions (% of total fuel combustion) of Lebanon in 2009 to that in 2011?
Provide a short and direct response. 0.97. What is the ratio of the CO2 emissions (% of total fuel combustion) in Latin America(all income levels) in 2010 to that in 2011?
Offer a terse response. 0.98. What is the ratio of the CO2 emissions (% of total fuel combustion) in Korea (Democratic) in 2010 to that in 2011?
Give a very brief answer. 0.7. What is the ratio of the CO2 emissions (% of total fuel combustion) in Lebanon in 2010 to that in 2011?
Provide a succinct answer. 1.01. What is the difference between the highest and the second highest CO2 emissions (% of total fuel combustion) in Latin America(all income levels)?
Give a very brief answer. 0.68. What is the difference between the highest and the second highest CO2 emissions (% of total fuel combustion) of Brunei Darussalam?
Provide a short and direct response. 0.69. What is the difference between the highest and the second highest CO2 emissions (% of total fuel combustion) in Korea (Democratic)?
Your response must be concise. 0.88. What is the difference between the highest and the second highest CO2 emissions (% of total fuel combustion) in Lebanon?
Provide a short and direct response. 0.42. What is the difference between the highest and the lowest CO2 emissions (% of total fuel combustion) in Latin America(all income levels)?
Ensure brevity in your answer.  1.33. What is the difference between the highest and the lowest CO2 emissions (% of total fuel combustion) in Brunei Darussalam?
Your answer should be very brief. 2.08. What is the difference between the highest and the lowest CO2 emissions (% of total fuel combustion) of Korea (Democratic)?
Give a very brief answer. 1.6. What is the difference between the highest and the lowest CO2 emissions (% of total fuel combustion) of Lebanon?
Your response must be concise. 2.97. 